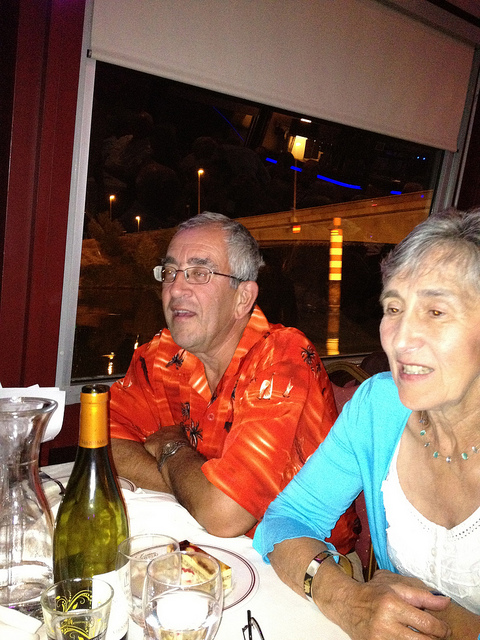Describe a realistic short scenario for this image. An elderly couple, enjoying a quiet dinner at a cozy restaurant, reminiscing about their past travels and shared experiences. 